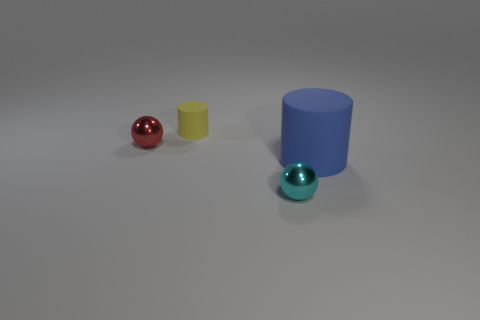Is there anything else that is the same size as the blue rubber thing?
Make the answer very short. No. The cyan thing that is the same size as the red metal ball is what shape?
Offer a terse response. Sphere. How many objects are large cylinders to the right of the small yellow thing or balls?
Keep it short and to the point. 3. Are there more big blue objects that are in front of the big matte object than balls right of the small cyan sphere?
Your answer should be compact. No. Are the yellow cylinder and the blue cylinder made of the same material?
Ensure brevity in your answer.  Yes. What shape is the thing that is behind the cyan shiny object and in front of the red metal ball?
Ensure brevity in your answer.  Cylinder. What is the shape of the big thing that is made of the same material as the small cylinder?
Offer a very short reply. Cylinder. Are there any small purple metal cylinders?
Provide a succinct answer. No. Are there any tiny things to the right of the small metal thing behind the big rubber cylinder?
Give a very brief answer. Yes. There is a large blue object that is the same shape as the yellow matte thing; what is its material?
Give a very brief answer. Rubber. 